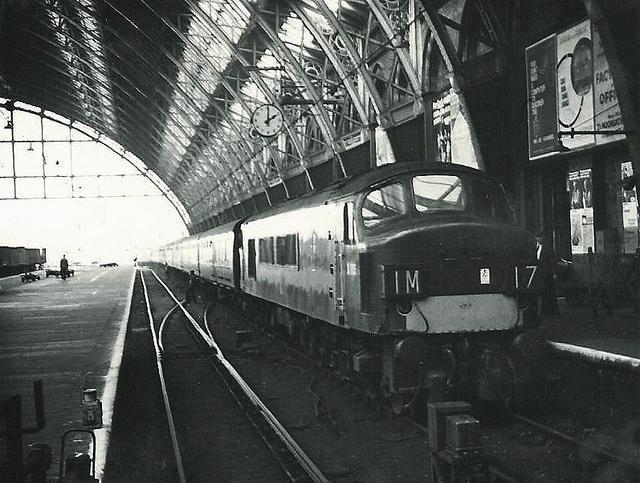How many black cars are driving to the left of the bus?
Give a very brief answer. 0. 